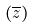Convert formula to latex. <formula><loc_0><loc_0><loc_500><loc_500>( \overline { z } )</formula> 